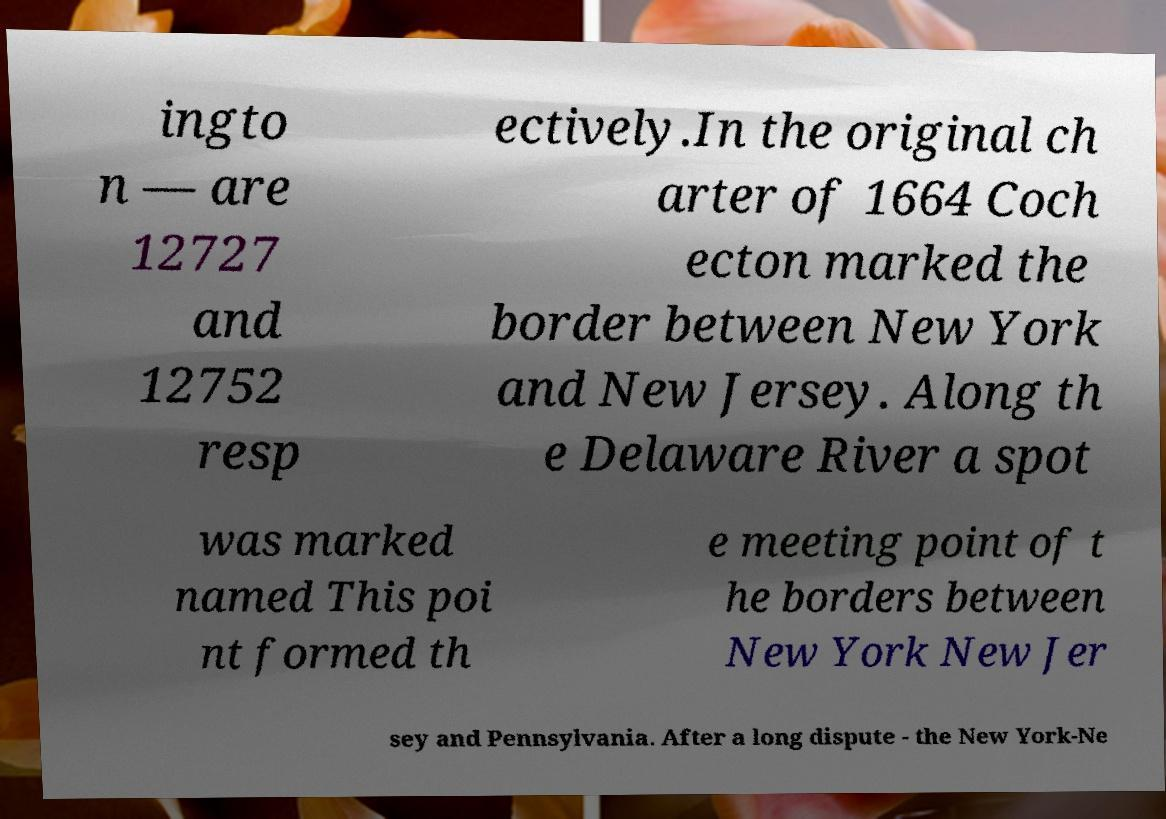Can you read and provide the text displayed in the image?This photo seems to have some interesting text. Can you extract and type it out for me? ingto n — are 12727 and 12752 resp ectively.In the original ch arter of 1664 Coch ecton marked the border between New York and New Jersey. Along th e Delaware River a spot was marked named This poi nt formed th e meeting point of t he borders between New York New Jer sey and Pennsylvania. After a long dispute - the New York-Ne 